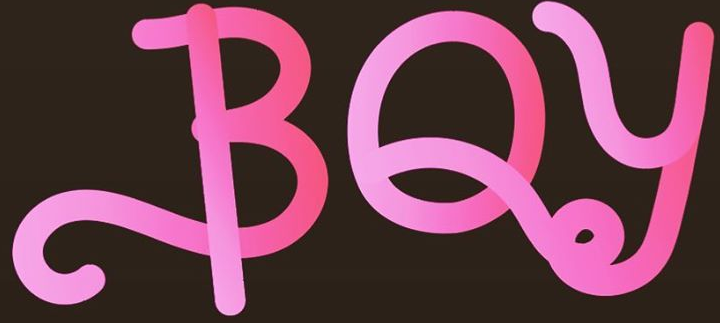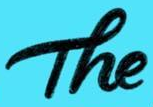What words are shown in these images in order, separated by a semicolon? BOy; The 